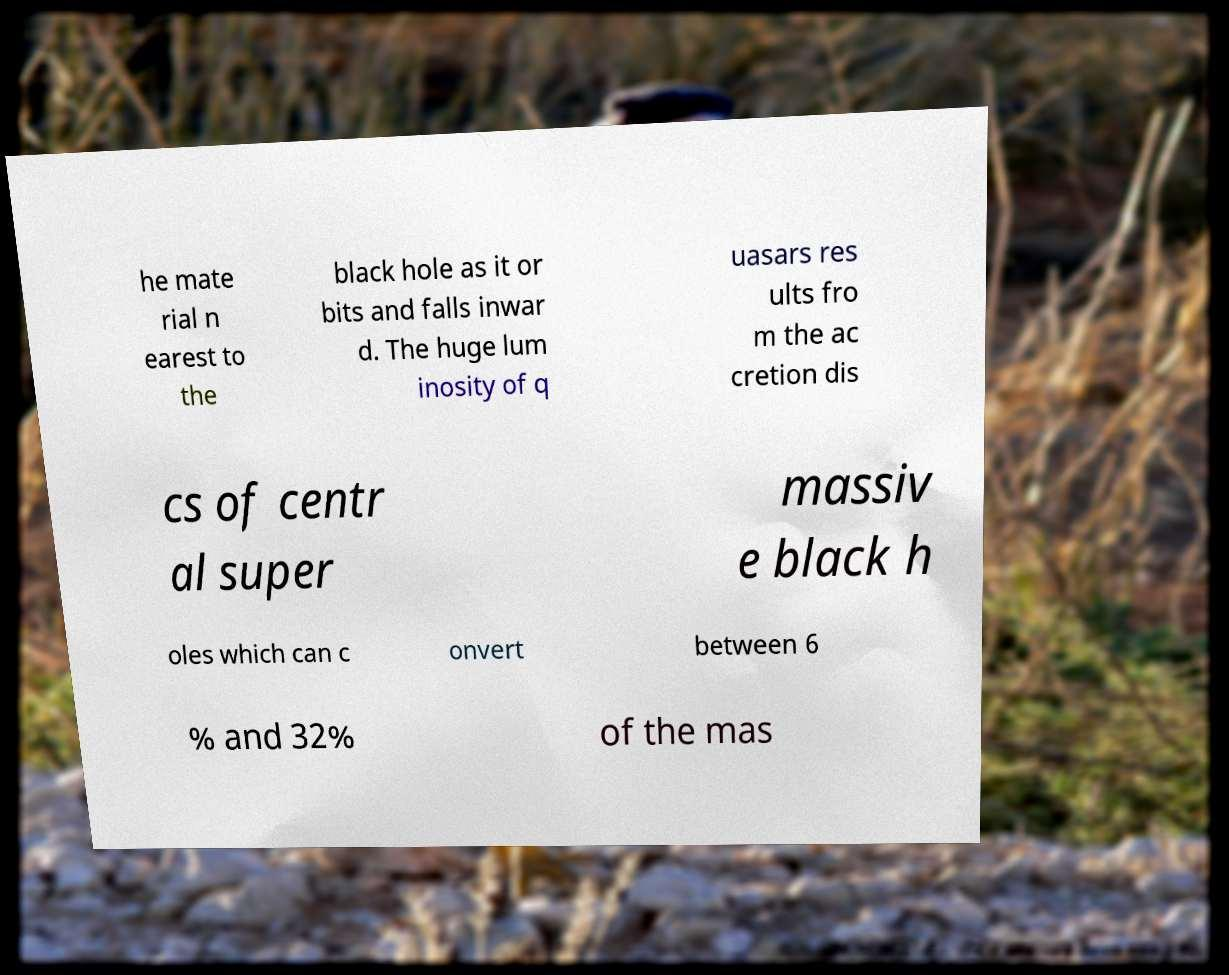Could you extract and type out the text from this image? he mate rial n earest to the black hole as it or bits and falls inwar d. The huge lum inosity of q uasars res ults fro m the ac cretion dis cs of centr al super massiv e black h oles which can c onvert between 6 % and 32% of the mas 